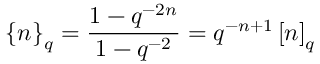Convert formula to latex. <formula><loc_0><loc_0><loc_500><loc_500>\left \{ n \right \} _ { q } = \frac { 1 - q ^ { - 2 n } } { 1 - q ^ { - 2 } } = q ^ { - n + 1 } \left [ n \right ] _ { q }</formula> 